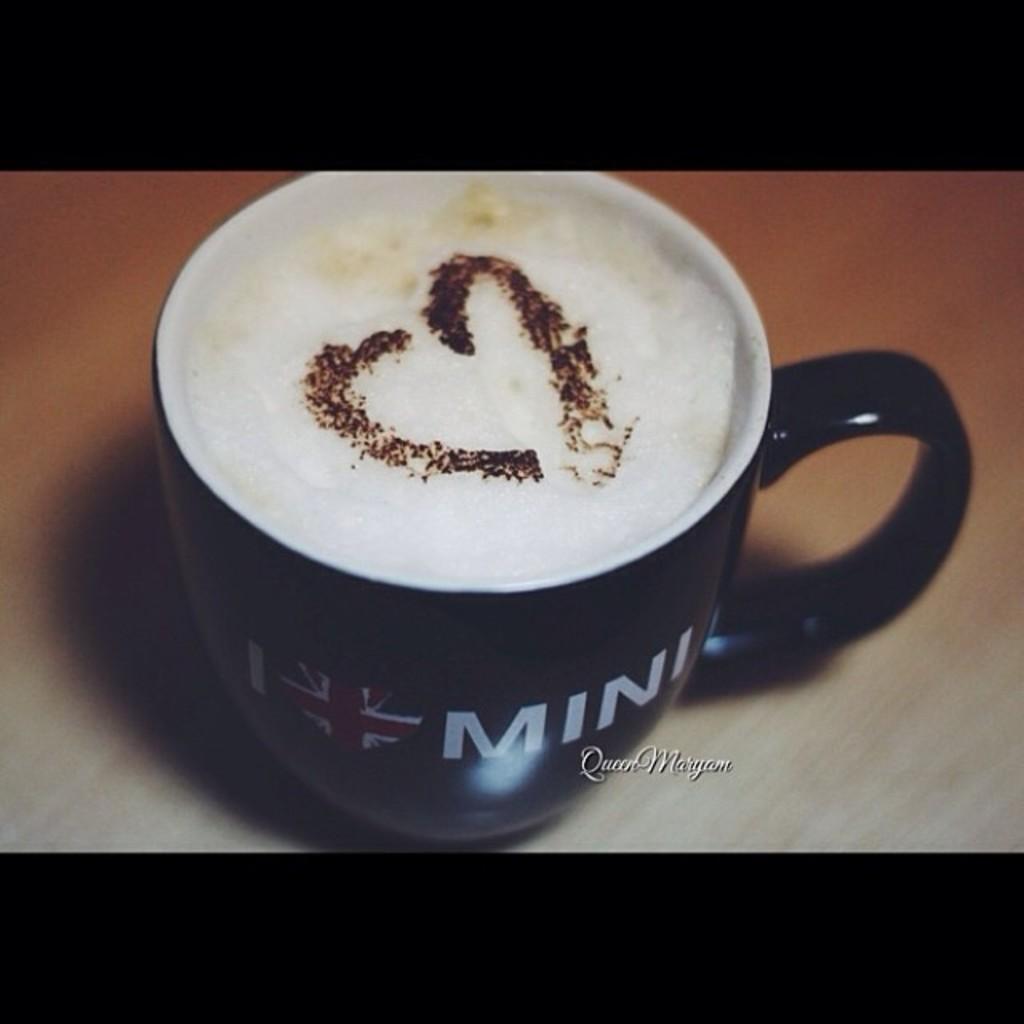How would you summarize this image in a sentence or two? This is the picture of a coffee mug. In it there is coffee. There is a heart shape on the top of the coffee mug. On the coffee mug there is written something and there is a flag. The coffee mug is placed on a table. 